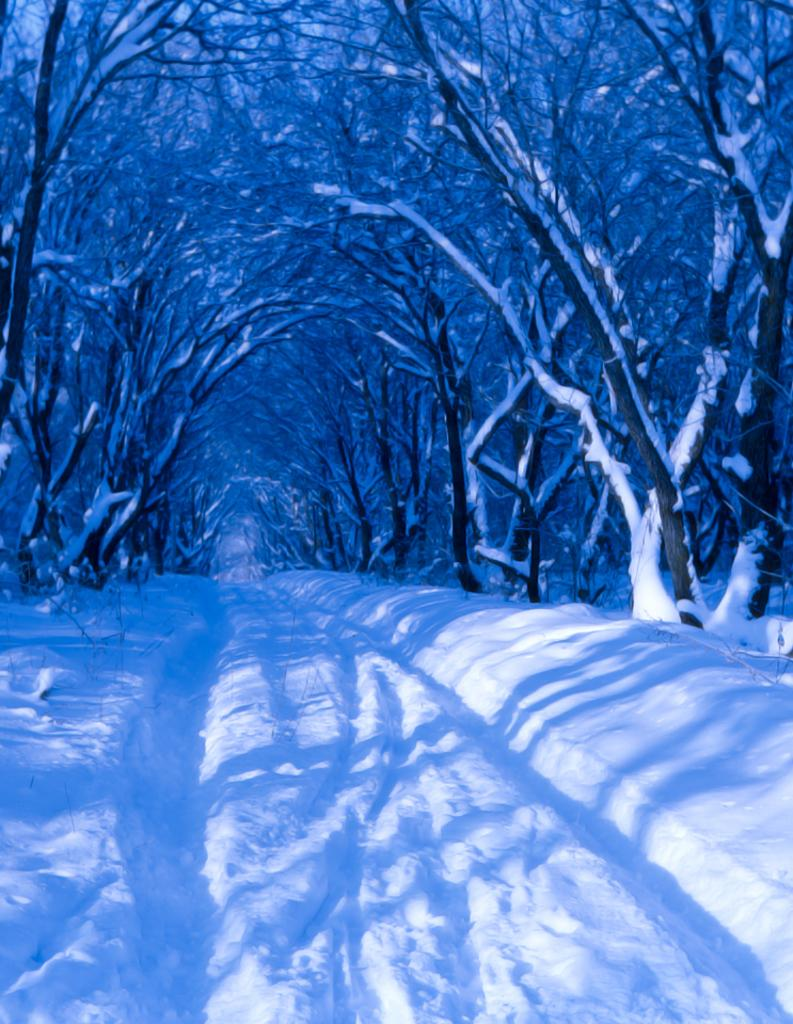What type of vegetation can be seen in the image? There are trees in the image. What is covering the trees in the image? The trees are covered with snow. What weather condition is depicted in the image? Snow is visible in the image. What type of jail can be seen in the image? There is no jail present in the image; it features trees covered with snow. How many feet are visible in the image? There are no feet visible in the image; it only shows trees covered with snow. 